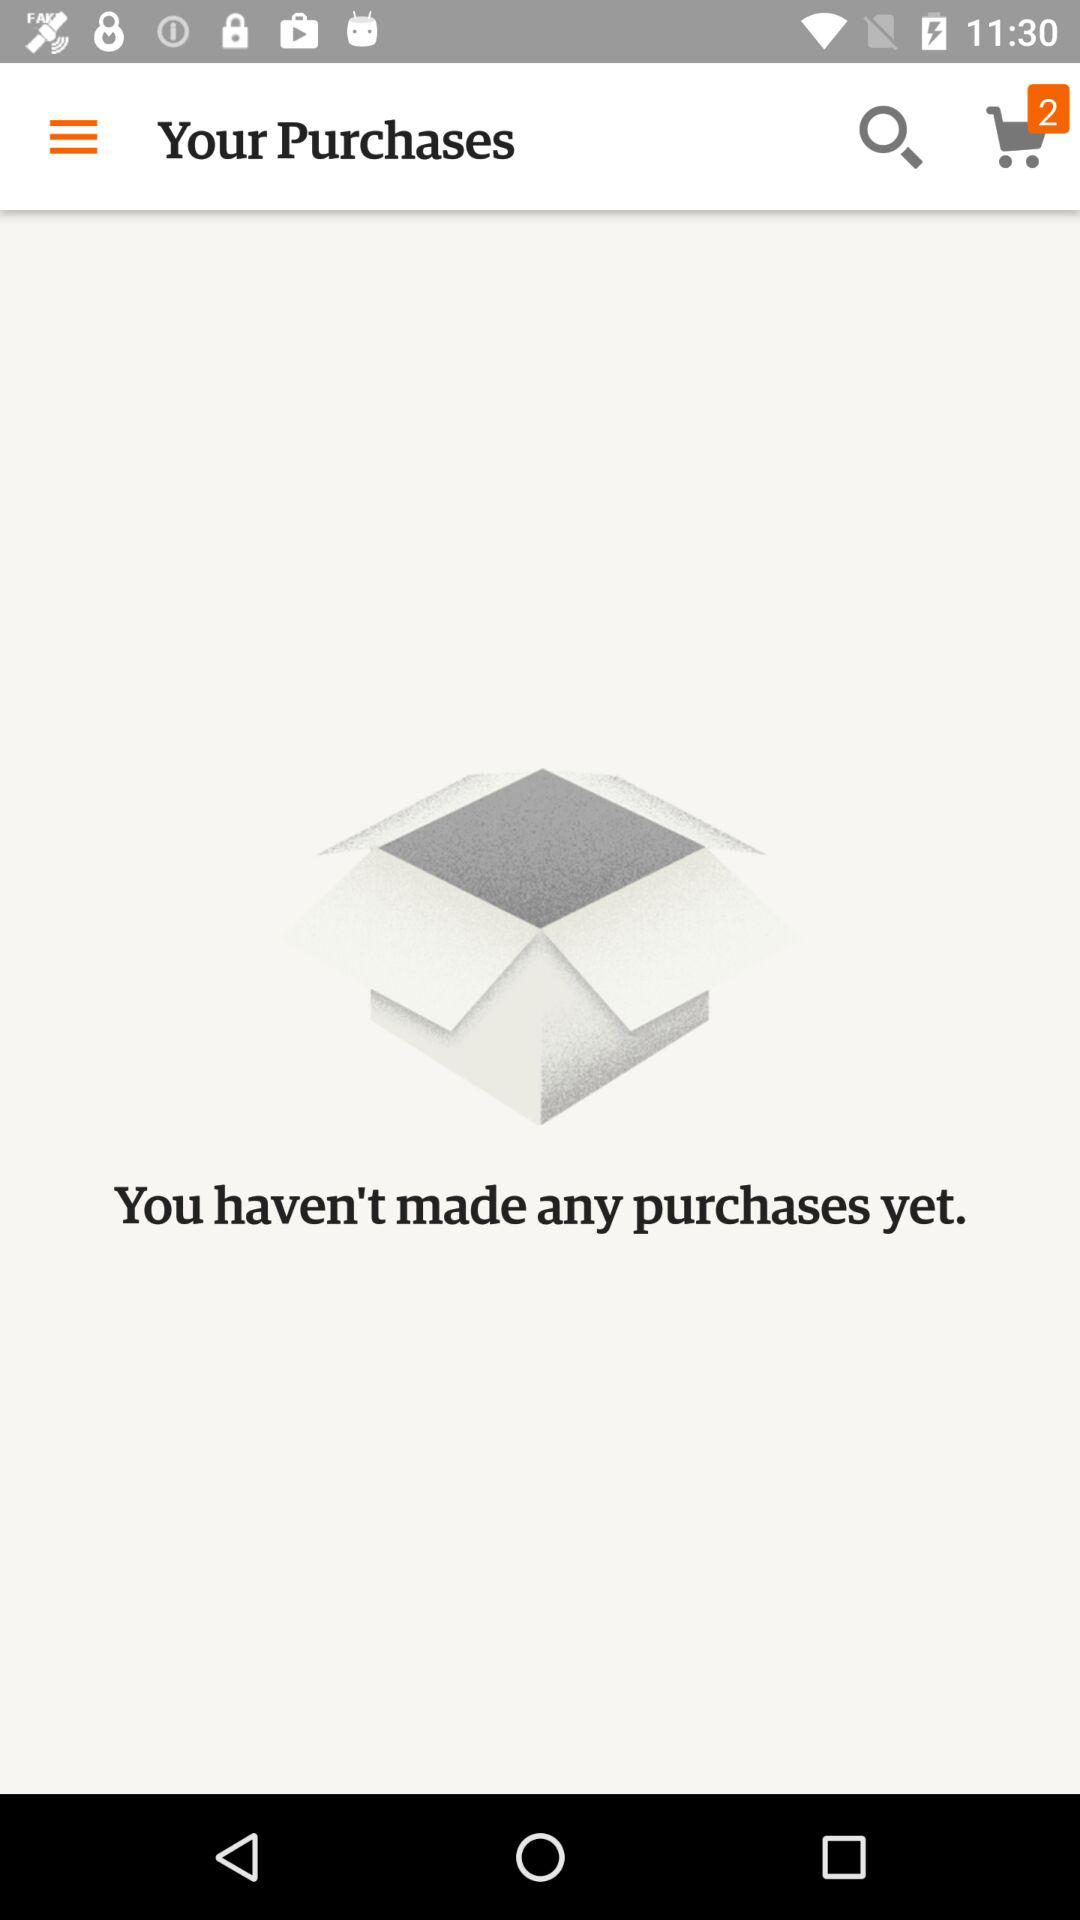How many purchases have I made?
Answer the question using a single word or phrase. 0 